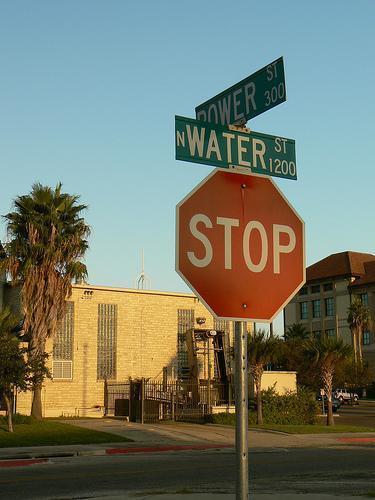How many street signs are in the photo?
Give a very brief answer. 2. How many buildings are there?
Give a very brief answer. 2. 